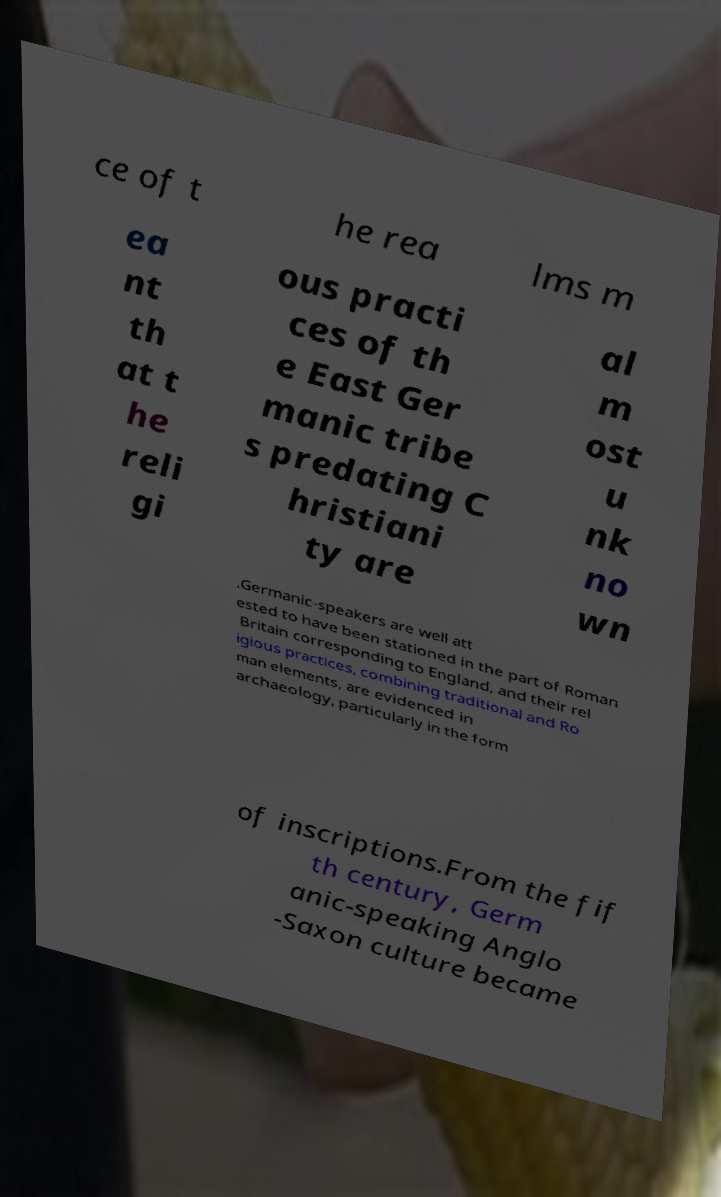Could you assist in decoding the text presented in this image and type it out clearly? ce of t he rea lms m ea nt th at t he reli gi ous practi ces of th e East Ger manic tribe s predating C hristiani ty are al m ost u nk no wn .Germanic-speakers are well att ested to have been stationed in the part of Roman Britain corresponding to England, and their rel igious practices, combining traditional and Ro man elements, are evidenced in archaeology, particularly in the form of inscriptions.From the fif th century, Germ anic-speaking Anglo -Saxon culture became 